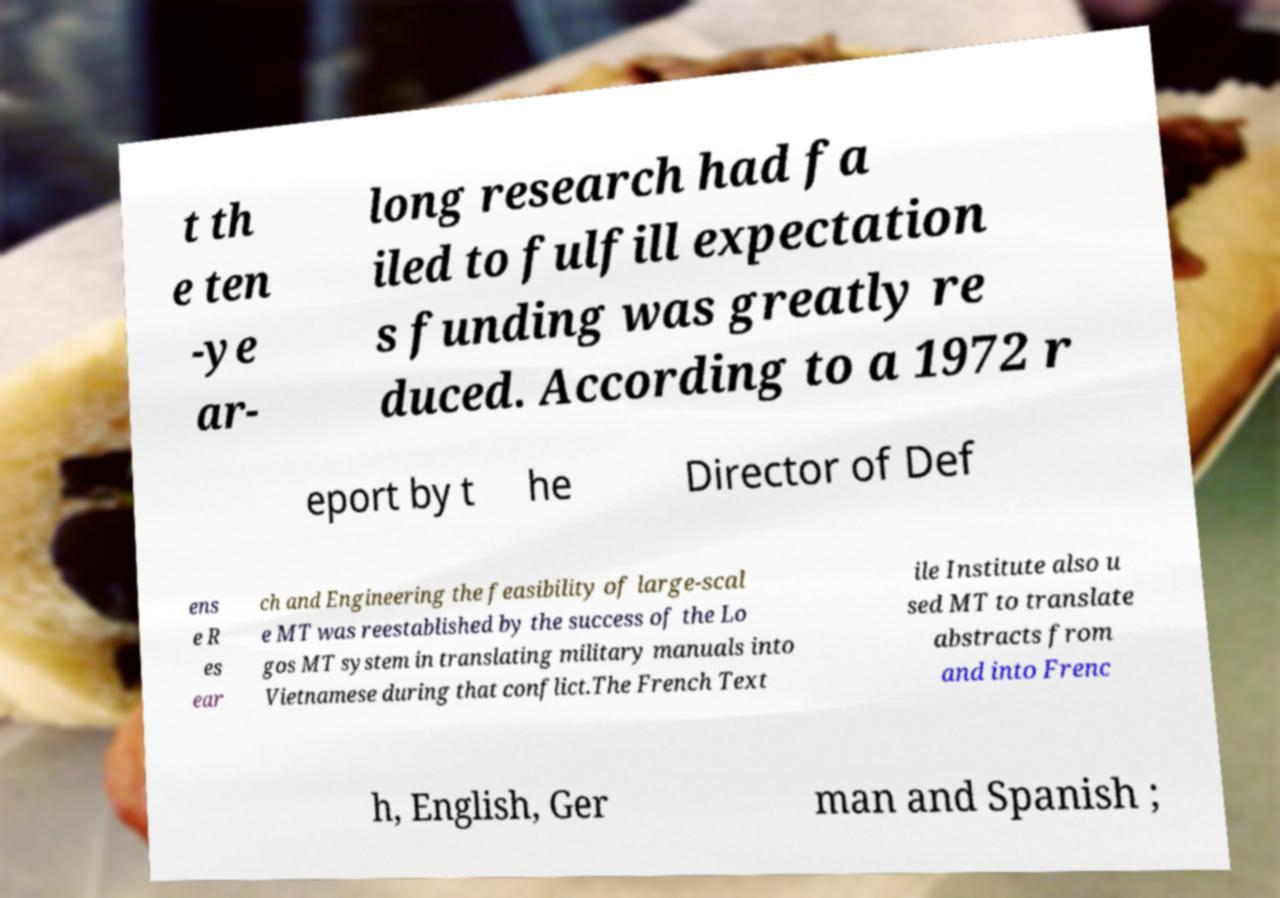For documentation purposes, I need the text within this image transcribed. Could you provide that? t th e ten -ye ar- long research had fa iled to fulfill expectation s funding was greatly re duced. According to a 1972 r eport by t he Director of Def ens e R es ear ch and Engineering the feasibility of large-scal e MT was reestablished by the success of the Lo gos MT system in translating military manuals into Vietnamese during that conflict.The French Text ile Institute also u sed MT to translate abstracts from and into Frenc h, English, Ger man and Spanish ; 